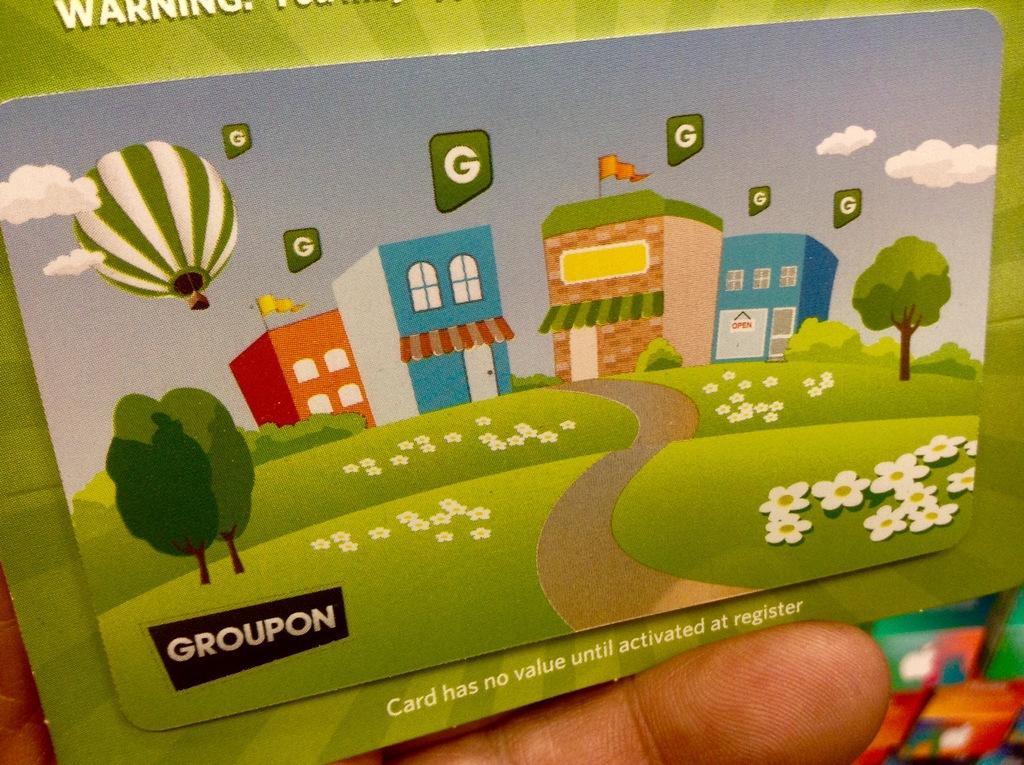Describe this image in one or two sentences. In this image in the center there is one person who is holding some board, in that board there is some text and some houses, trees and some flowers, walkway, grass and one parachute. 